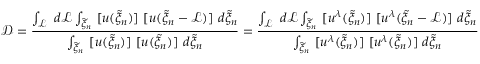<formula> <loc_0><loc_0><loc_500><loc_500>\mathcal { D } = \frac { \int _ { \mathcal { L } } d \mathcal { L } \int _ { \widetilde { \xi } _ { n } } [ u ( \widetilde { \xi } _ { n } ) ] [ u ( \widetilde { \xi } _ { n } - \mathcal { L } ) ] d \widetilde { \xi } _ { n } } { \int _ { \widetilde { \xi } _ { n } } [ u ( \widetilde { \xi } _ { n } ) ] [ u ( \widetilde { \xi } _ { n } ) ] d \widetilde { \xi } _ { n } } = \frac { \int _ { \mathcal { L } } d \mathcal { L } \int _ { \widetilde { \xi } _ { n } } [ u ^ { \lambda } ( \widetilde { \xi } _ { n } ) ] [ u ^ { \lambda } ( \widetilde { \xi } _ { n } - \mathcal { L } ) ] d \widetilde { \xi } _ { n } } { \int _ { \widetilde { \xi } _ { n } } [ u ^ { \lambda } ( \widetilde { \xi } _ { n } ) ] [ u ^ { \lambda } ( \widetilde { \xi } _ { n } ) ] d \widetilde { \xi } _ { n } }</formula> 